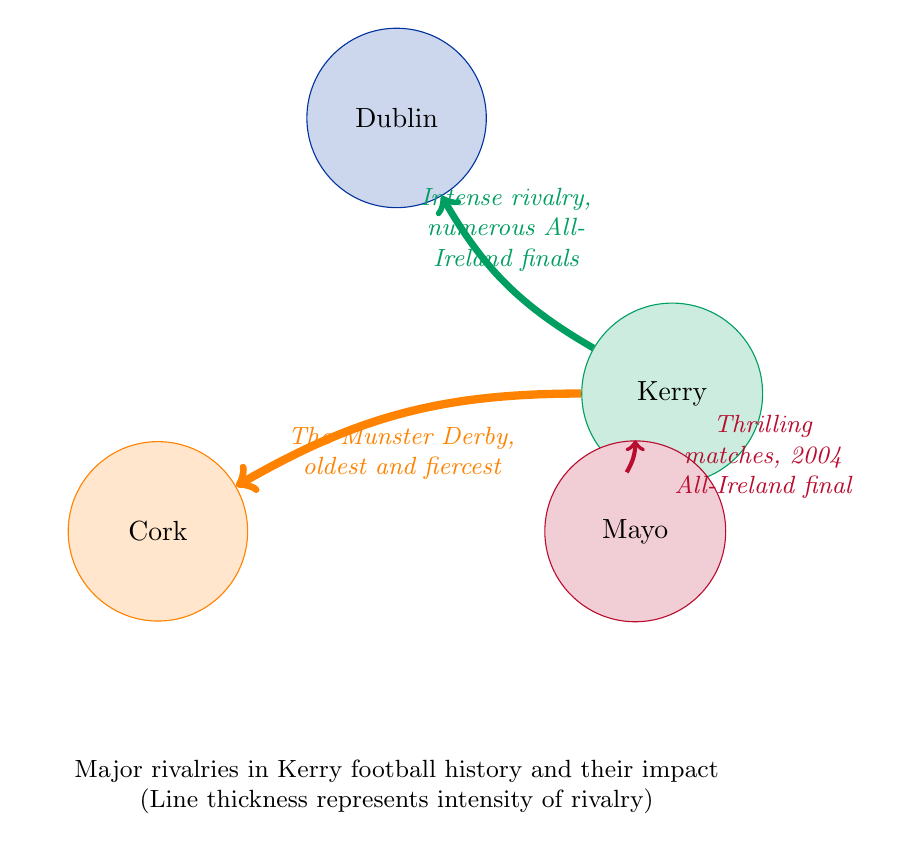What are the rival teams faced by Kerry in this diagram? The nodes connected to Kerry are Dublin, Cork, and Mayo. Each connection represents a rivalry. Therefore, the teams faced by Kerry are Dublin, Cork, and Mayo.
Answer: Dublin, Cork, Mayo Which rivalry has the highest intensity value? By examining the thickness of the lines that represent the rivalries, we see that the line connecting Kerry to Cork has the highest thickness and is labeled with a value of 30.
Answer: Cork How many total rivalries are depicted in the diagram? The diagram shows connections from Kerry to Dublin, Cork, and Mayo, amounting to three distinct rivalries.
Answer: 3 What is the description of the rivalry with Dublin? The description associated with the line between Kerry and Dublin mentions "Intense rivalry, numerous All-Ireland finals." This highlights the significance and competitiveness of their encounters.
Answer: Intense rivalry, numerous All-Ireland finals What happened in the 2004 final involving Mayo? The link between Kerry and Mayo states, "Thrilling matches, 2004 All-Ireland final," indicating that in 2004, Kerry faced Mayo and won—the match is particularly emphasized due to its memorable nature.
Answer: Kerry triumphed Which rivalry is known as The Munster Derby? The label for the line connecting Kerry to Cork specifically names this competition as "The Munster Derby," which is a well-known term in Gaelic football.
Answer: The Munster Derby What rivalry has the lowest intensity value? The diagram shows that the rivalry with Mayo has the lowest value of 15, as indicated by the thin line connecting Kerry to Mayo.
Answer: Mayo How do the descriptions of the rivalries reflect their historical significance? Each description provides context about the matches; for instance, the intense competition between Kerry and Dublin reflects historical significance through numerous All-Ireland finals, while Kerry-Cork demonstrates longevity as one of the oldest rivalries.
Answer: Historical significance reflected in descriptions 